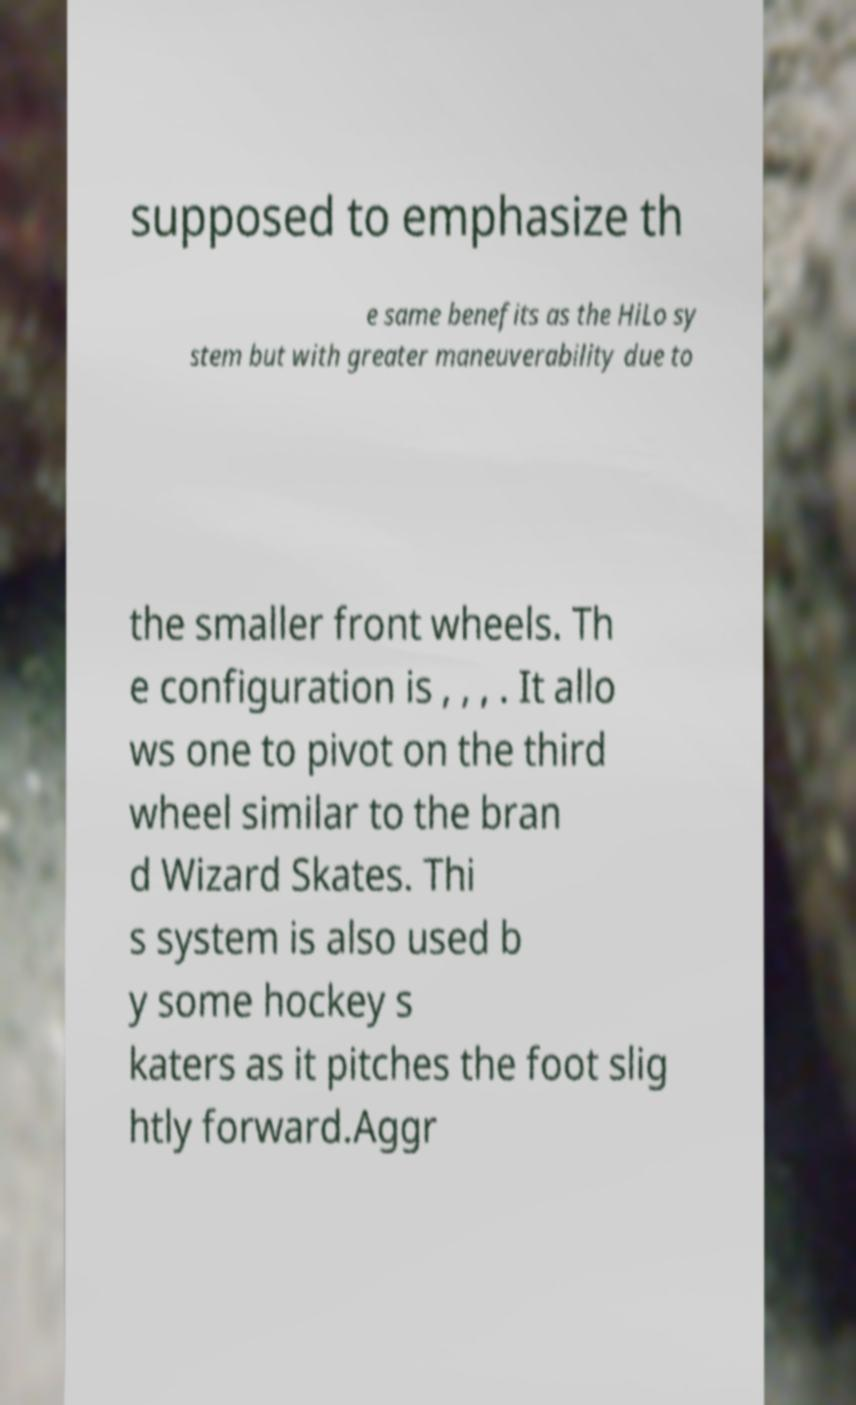Please identify and transcribe the text found in this image. supposed to emphasize th e same benefits as the HiLo sy stem but with greater maneuverability due to the smaller front wheels. Th e configuration is , , , . It allo ws one to pivot on the third wheel similar to the bran d Wizard Skates. Thi s system is also used b y some hockey s katers as it pitches the foot slig htly forward.Aggr 